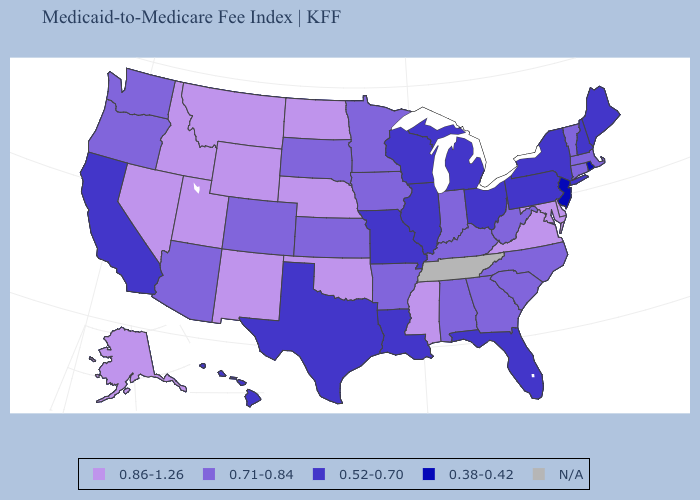What is the value of North Carolina?
Short answer required. 0.71-0.84. What is the highest value in the South ?
Give a very brief answer. 0.86-1.26. What is the lowest value in the USA?
Quick response, please. 0.38-0.42. Name the states that have a value in the range 0.86-1.26?
Concise answer only. Alaska, Delaware, Idaho, Maryland, Mississippi, Montana, Nebraska, Nevada, New Mexico, North Dakota, Oklahoma, Utah, Virginia, Wyoming. Among the states that border Nebraska , does Missouri have the lowest value?
Keep it brief. Yes. What is the lowest value in the USA?
Be succinct. 0.38-0.42. Does the map have missing data?
Concise answer only. Yes. Does New York have the highest value in the Northeast?
Write a very short answer. No. Name the states that have a value in the range 0.86-1.26?
Keep it brief. Alaska, Delaware, Idaho, Maryland, Mississippi, Montana, Nebraska, Nevada, New Mexico, North Dakota, Oklahoma, Utah, Virginia, Wyoming. Among the states that border Arizona , does Colorado have the highest value?
Write a very short answer. No. What is the value of Vermont?
Give a very brief answer. 0.71-0.84. What is the value of Virginia?
Be succinct. 0.86-1.26. Does the map have missing data?
Concise answer only. Yes. Which states have the highest value in the USA?
Answer briefly. Alaska, Delaware, Idaho, Maryland, Mississippi, Montana, Nebraska, Nevada, New Mexico, North Dakota, Oklahoma, Utah, Virginia, Wyoming. Name the states that have a value in the range 0.71-0.84?
Short answer required. Alabama, Arizona, Arkansas, Colorado, Connecticut, Georgia, Indiana, Iowa, Kansas, Kentucky, Massachusetts, Minnesota, North Carolina, Oregon, South Carolina, South Dakota, Vermont, Washington, West Virginia. 